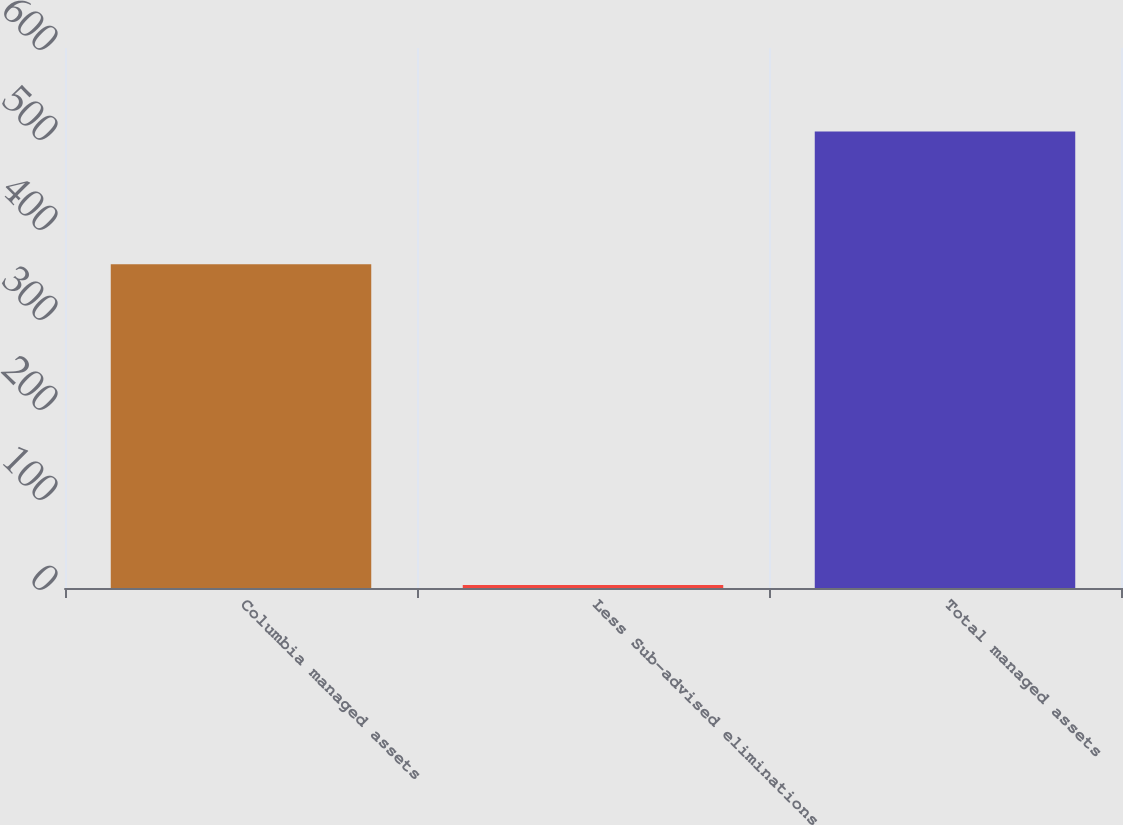<chart> <loc_0><loc_0><loc_500><loc_500><bar_chart><fcel>Columbia managed assets<fcel>Less Sub-advised eliminations<fcel>Total managed assets<nl><fcel>359.7<fcel>3.3<fcel>507.3<nl></chart> 